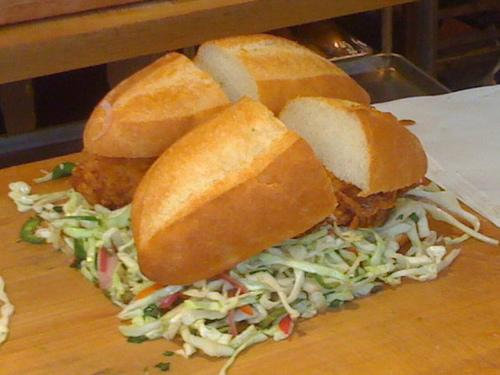How many people is this food for most likely? Please explain your reasoning. two. Looks like there are two sandwiches there. 